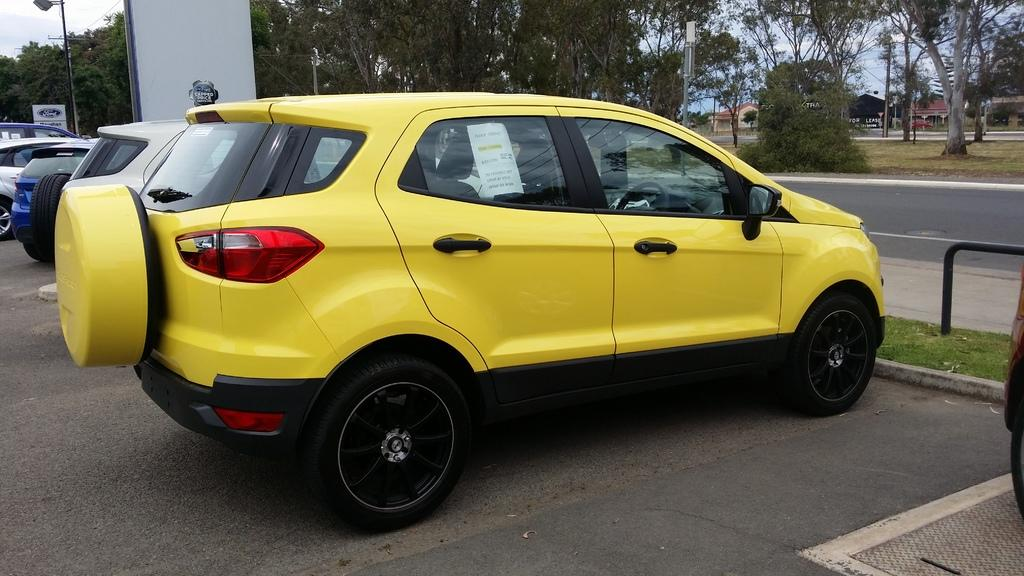What can be seen beside the road in the image? There are cars beside the road in the image. What type of vegetation is visible at the top of the image? There are trees at the top of the image. What structure can be seen in the top left of the image? There is a street pole in the top left of the image. What type of spark can be seen coming from the trees in the image? There is no spark present in the image; it only features cars beside the road, trees at the top, and a street pole in the top left. How many ghosts are visible in the image? There are no ghosts present in the image. 